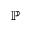Convert formula to latex. <formula><loc_0><loc_0><loc_500><loc_500>\mathbb { P }</formula> 